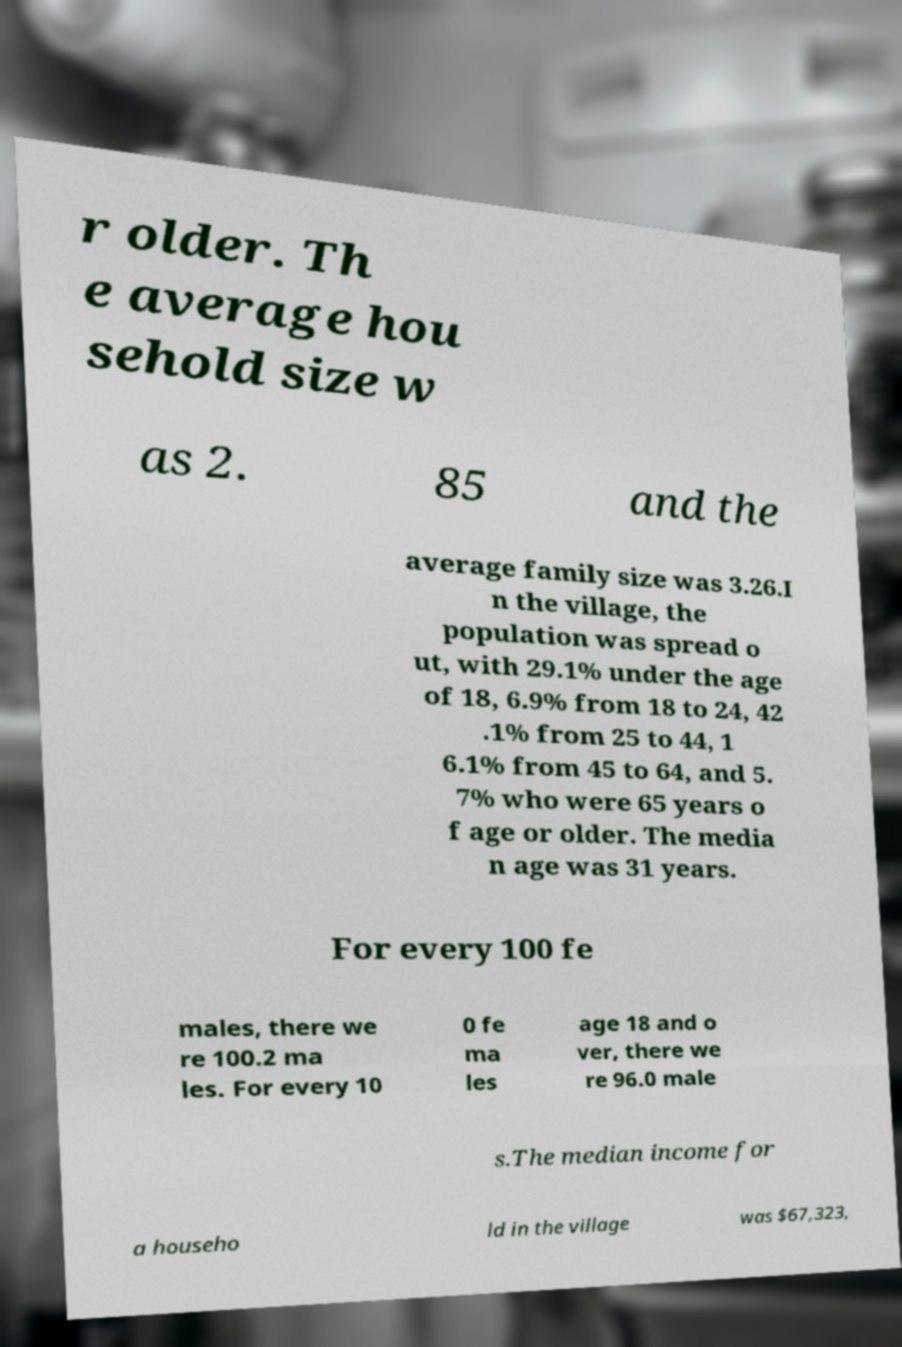Can you read and provide the text displayed in the image?This photo seems to have some interesting text. Can you extract and type it out for me? r older. Th e average hou sehold size w as 2. 85 and the average family size was 3.26.I n the village, the population was spread o ut, with 29.1% under the age of 18, 6.9% from 18 to 24, 42 .1% from 25 to 44, 1 6.1% from 45 to 64, and 5. 7% who were 65 years o f age or older. The media n age was 31 years. For every 100 fe males, there we re 100.2 ma les. For every 10 0 fe ma les age 18 and o ver, there we re 96.0 male s.The median income for a househo ld in the village was $67,323, 